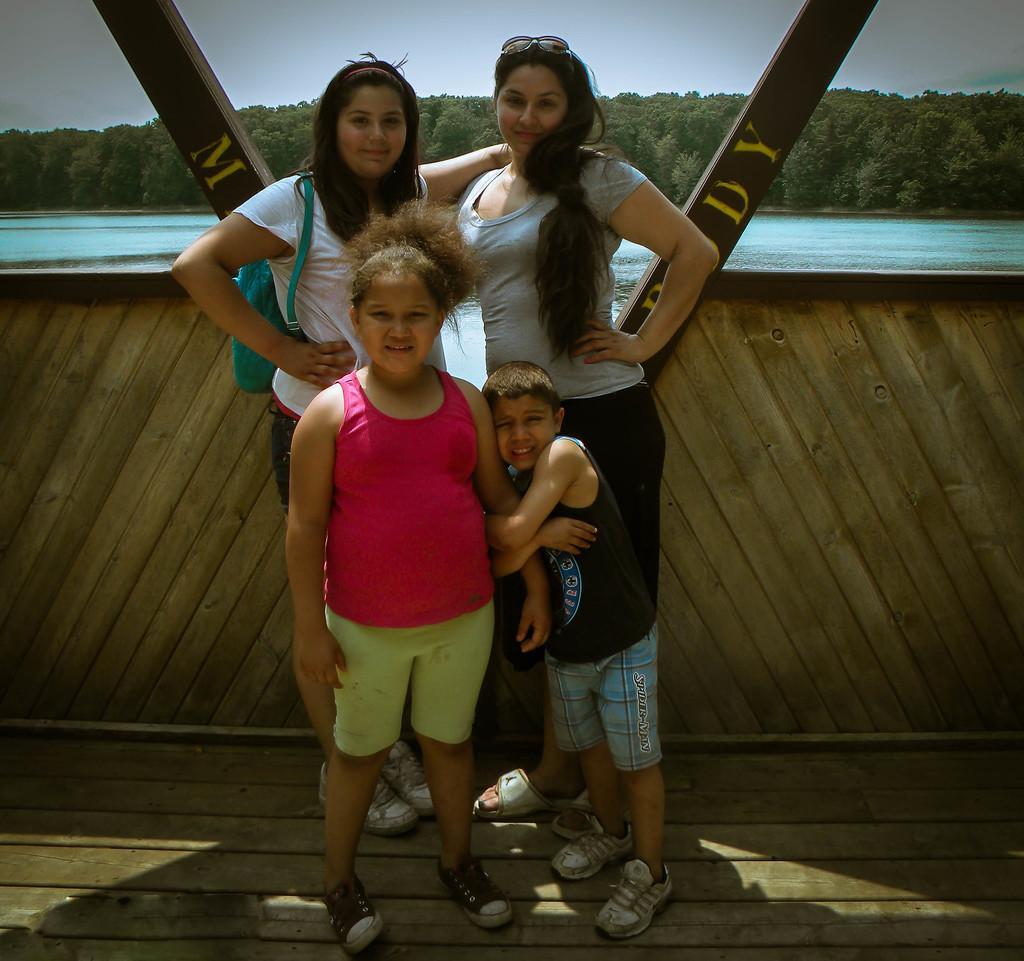Could you give a brief overview of what you see in this image? In this picture we can see four people on the ground and in the background we can see a fence, water, trees and the sky. 